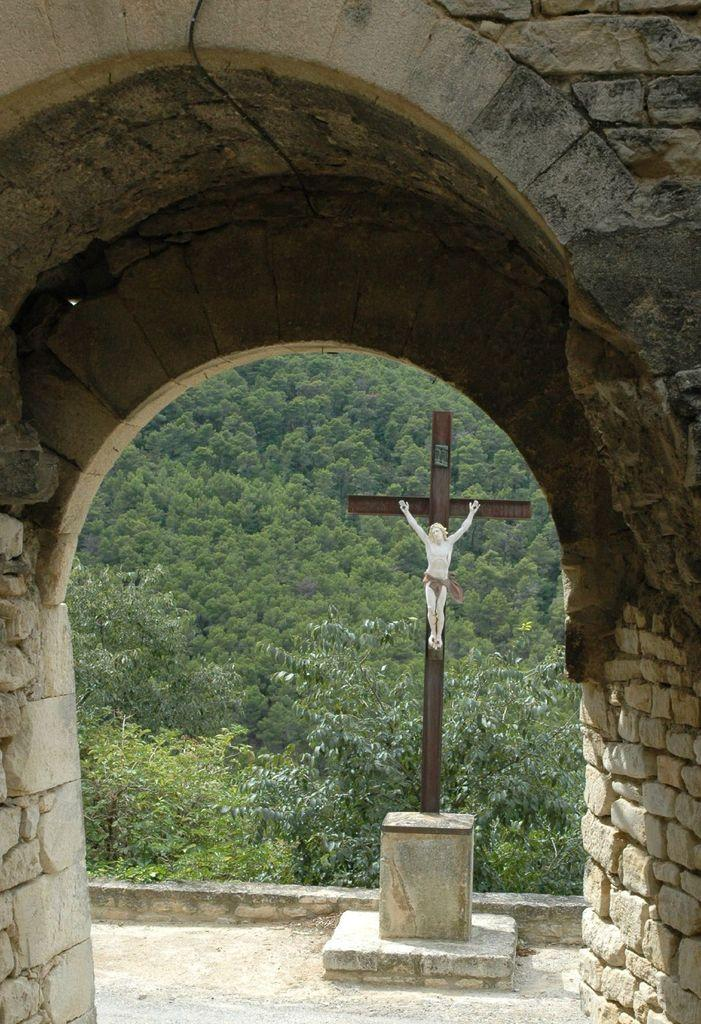What type of structure is present in the image? There is an arch in the image. What can be seen in the background of the image? There is a statue and trees in the background of the image. How many fairies are flying around the statue in the image? There are no fairies present in the image; it only features an arch, a statue, and trees in the background. 